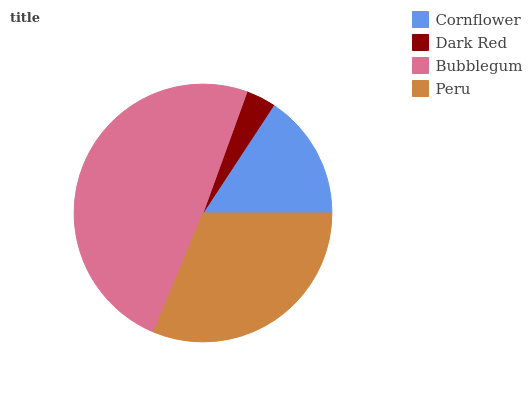Is Dark Red the minimum?
Answer yes or no. Yes. Is Bubblegum the maximum?
Answer yes or no. Yes. Is Bubblegum the minimum?
Answer yes or no. No. Is Dark Red the maximum?
Answer yes or no. No. Is Bubblegum greater than Dark Red?
Answer yes or no. Yes. Is Dark Red less than Bubblegum?
Answer yes or no. Yes. Is Dark Red greater than Bubblegum?
Answer yes or no. No. Is Bubblegum less than Dark Red?
Answer yes or no. No. Is Peru the high median?
Answer yes or no. Yes. Is Cornflower the low median?
Answer yes or no. Yes. Is Cornflower the high median?
Answer yes or no. No. Is Dark Red the low median?
Answer yes or no. No. 